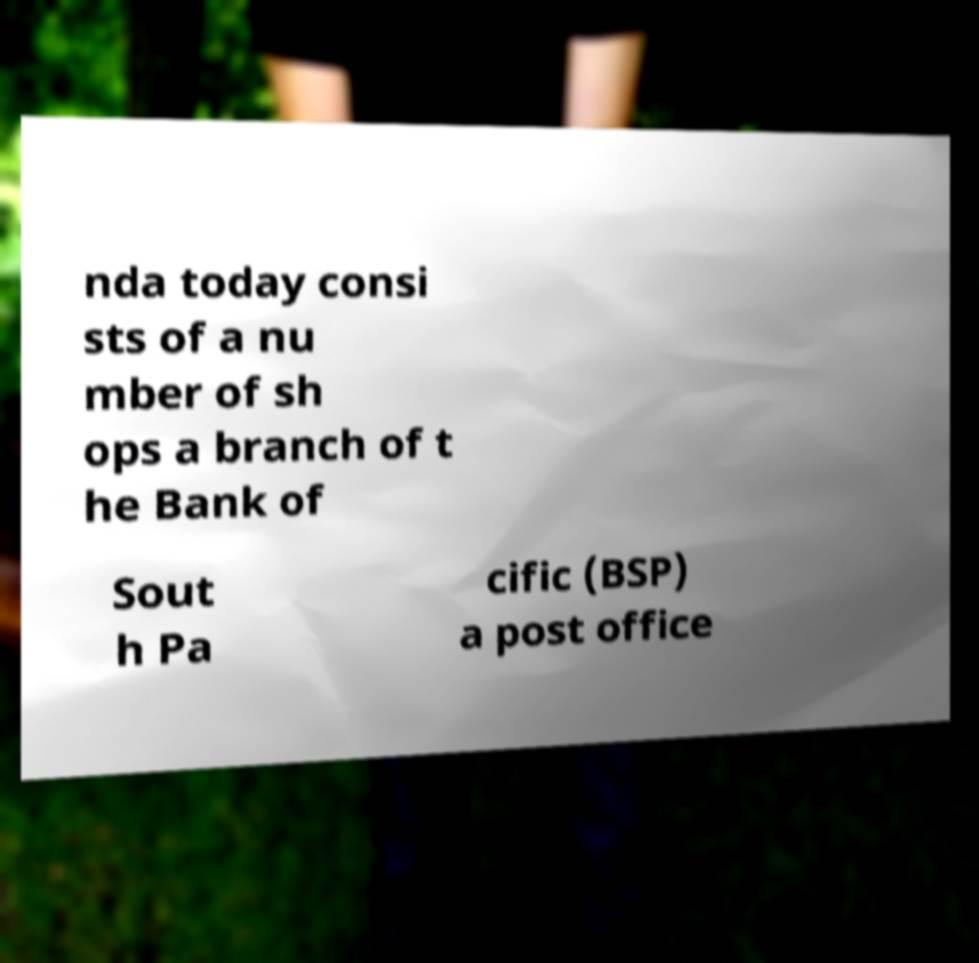There's text embedded in this image that I need extracted. Can you transcribe it verbatim? nda today consi sts of a nu mber of sh ops a branch of t he Bank of Sout h Pa cific (BSP) a post office 